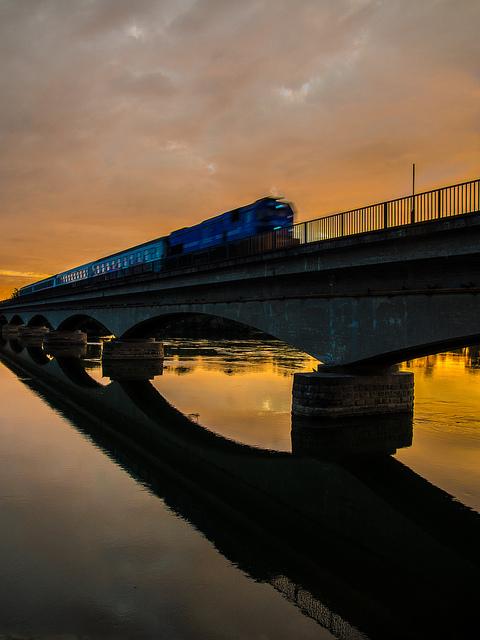Is there a train in this image?
Give a very brief answer. Yes. What time was it when the photo was taken?
Be succinct. Evening. What kind of architectural design keeps the bridge strong?
Give a very brief answer. Arches. 